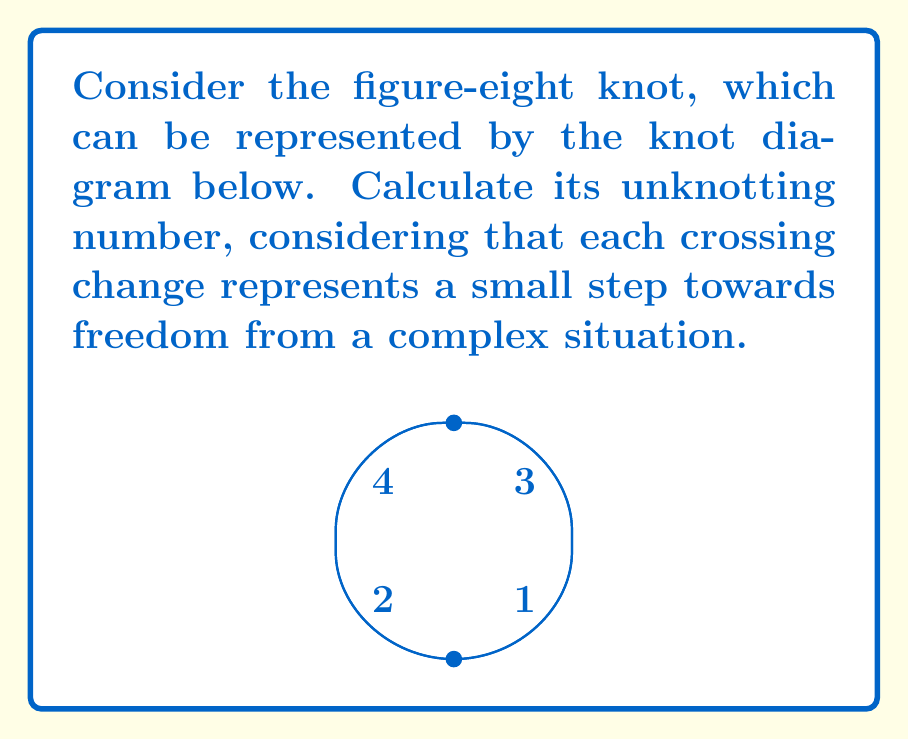Show me your answer to this math problem. To calculate the unknotting number of the figure-eight knot, we need to determine the minimum number of crossing changes required to transform it into the unknot. Let's approach this step-by-step:

1) First, we need to understand what the figure-eight knot looks like. It has 4 crossings in its minimal diagram, as shown in the figure.

2) The unknotting number is always less than or equal to the number of crossings in a minimal diagram. So, we know that the unknotting number is at most 4.

3) Let's consider what happens when we change one crossing:
   - Changing any single crossing doesn't unknot the figure-eight knot.
   - This means the unknotting number is at least 2.

4) Now, let's consider changing two crossings:
   - If we change the crossings labeled 1 and 3, or 2 and 4, we can unknot the figure-eight knot.
   - For example, changing crossings 1 and 3 transforms the figure-eight knot into a simple loop (the unknot).

5) We can prove that it's impossible to unknot the figure-eight knot with just one crossing change:
   - The figure-eight knot has a property called "chirality", which means it's not equivalent to its mirror image.
   - A single crossing change can't change a chiral knot into an achiral knot (like the unknot).

6) Therefore, the minimum number of crossing changes required to unknot the figure-eight knot is 2.

In the context of the given persona, each crossing change can be seen as a significant step towards freedom from a complex and entangled situation, with the unknot representing complete liberation.
Answer: 2 